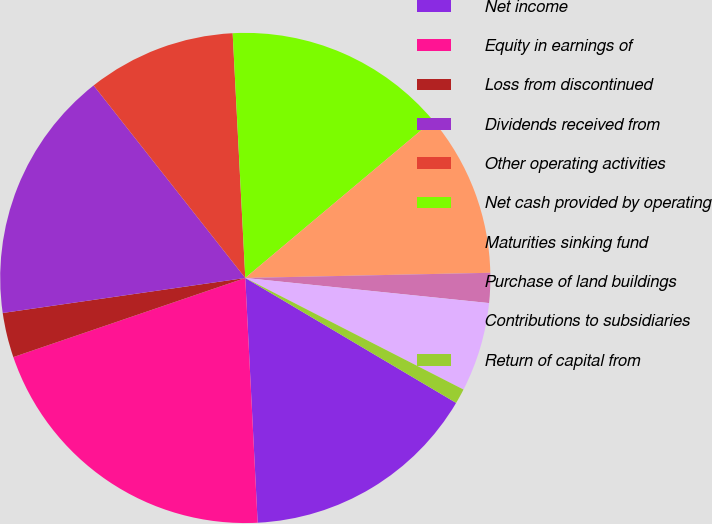<chart> <loc_0><loc_0><loc_500><loc_500><pie_chart><fcel>Net income<fcel>Equity in earnings of<fcel>Loss from discontinued<fcel>Dividends received from<fcel>Other operating activities<fcel>Net cash provided by operating<fcel>Maturities sinking fund<fcel>Purchase of land buildings<fcel>Contributions to subsidiaries<fcel>Return of capital from<nl><fcel>15.68%<fcel>20.57%<fcel>2.95%<fcel>16.66%<fcel>9.8%<fcel>14.7%<fcel>10.78%<fcel>1.97%<fcel>5.89%<fcel>0.99%<nl></chart> 